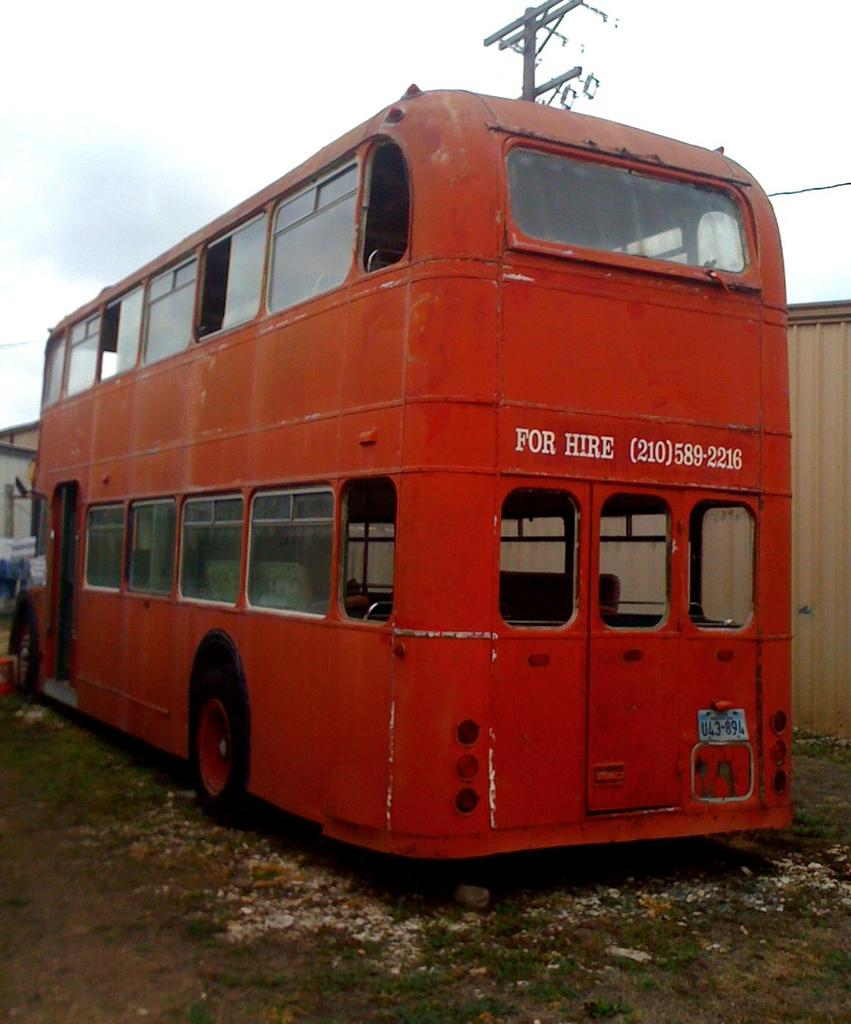What type of vehicle is in the image? There is a red double-decker bus in the image. Where is the bus located in relation to other objects? The bus is parked in the front. What structure can be seen behind the bus? There is a shed behind the bus. What other object is present in the image? An electrical pole is present in the image. What type of liquid can be seen flowing from the church in the image? There is no church or liquid present in the image; it features a red double-decker bus, a shed, and an electrical pole. 